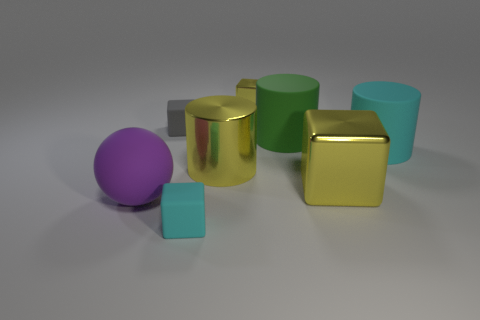Can you discuss the lighting seen in the image? The image displays soft lighting conditions, with a diffuse light source that creates gentle shadows on the ground. There are subtle highlights on the reflective objects, suggesting a position of the light source above and slightly to the right of the scene. How do the shadows contribute to the perception of the objects' shapes? The shadows provide visual cues about the three-dimensional forms of the objects. They help us understand the spatial relationships between the objects and the surface they are on. For instance, the elongated shadow of the cylinder indicates its cylindrical shape and its orientation relative to the light source. 